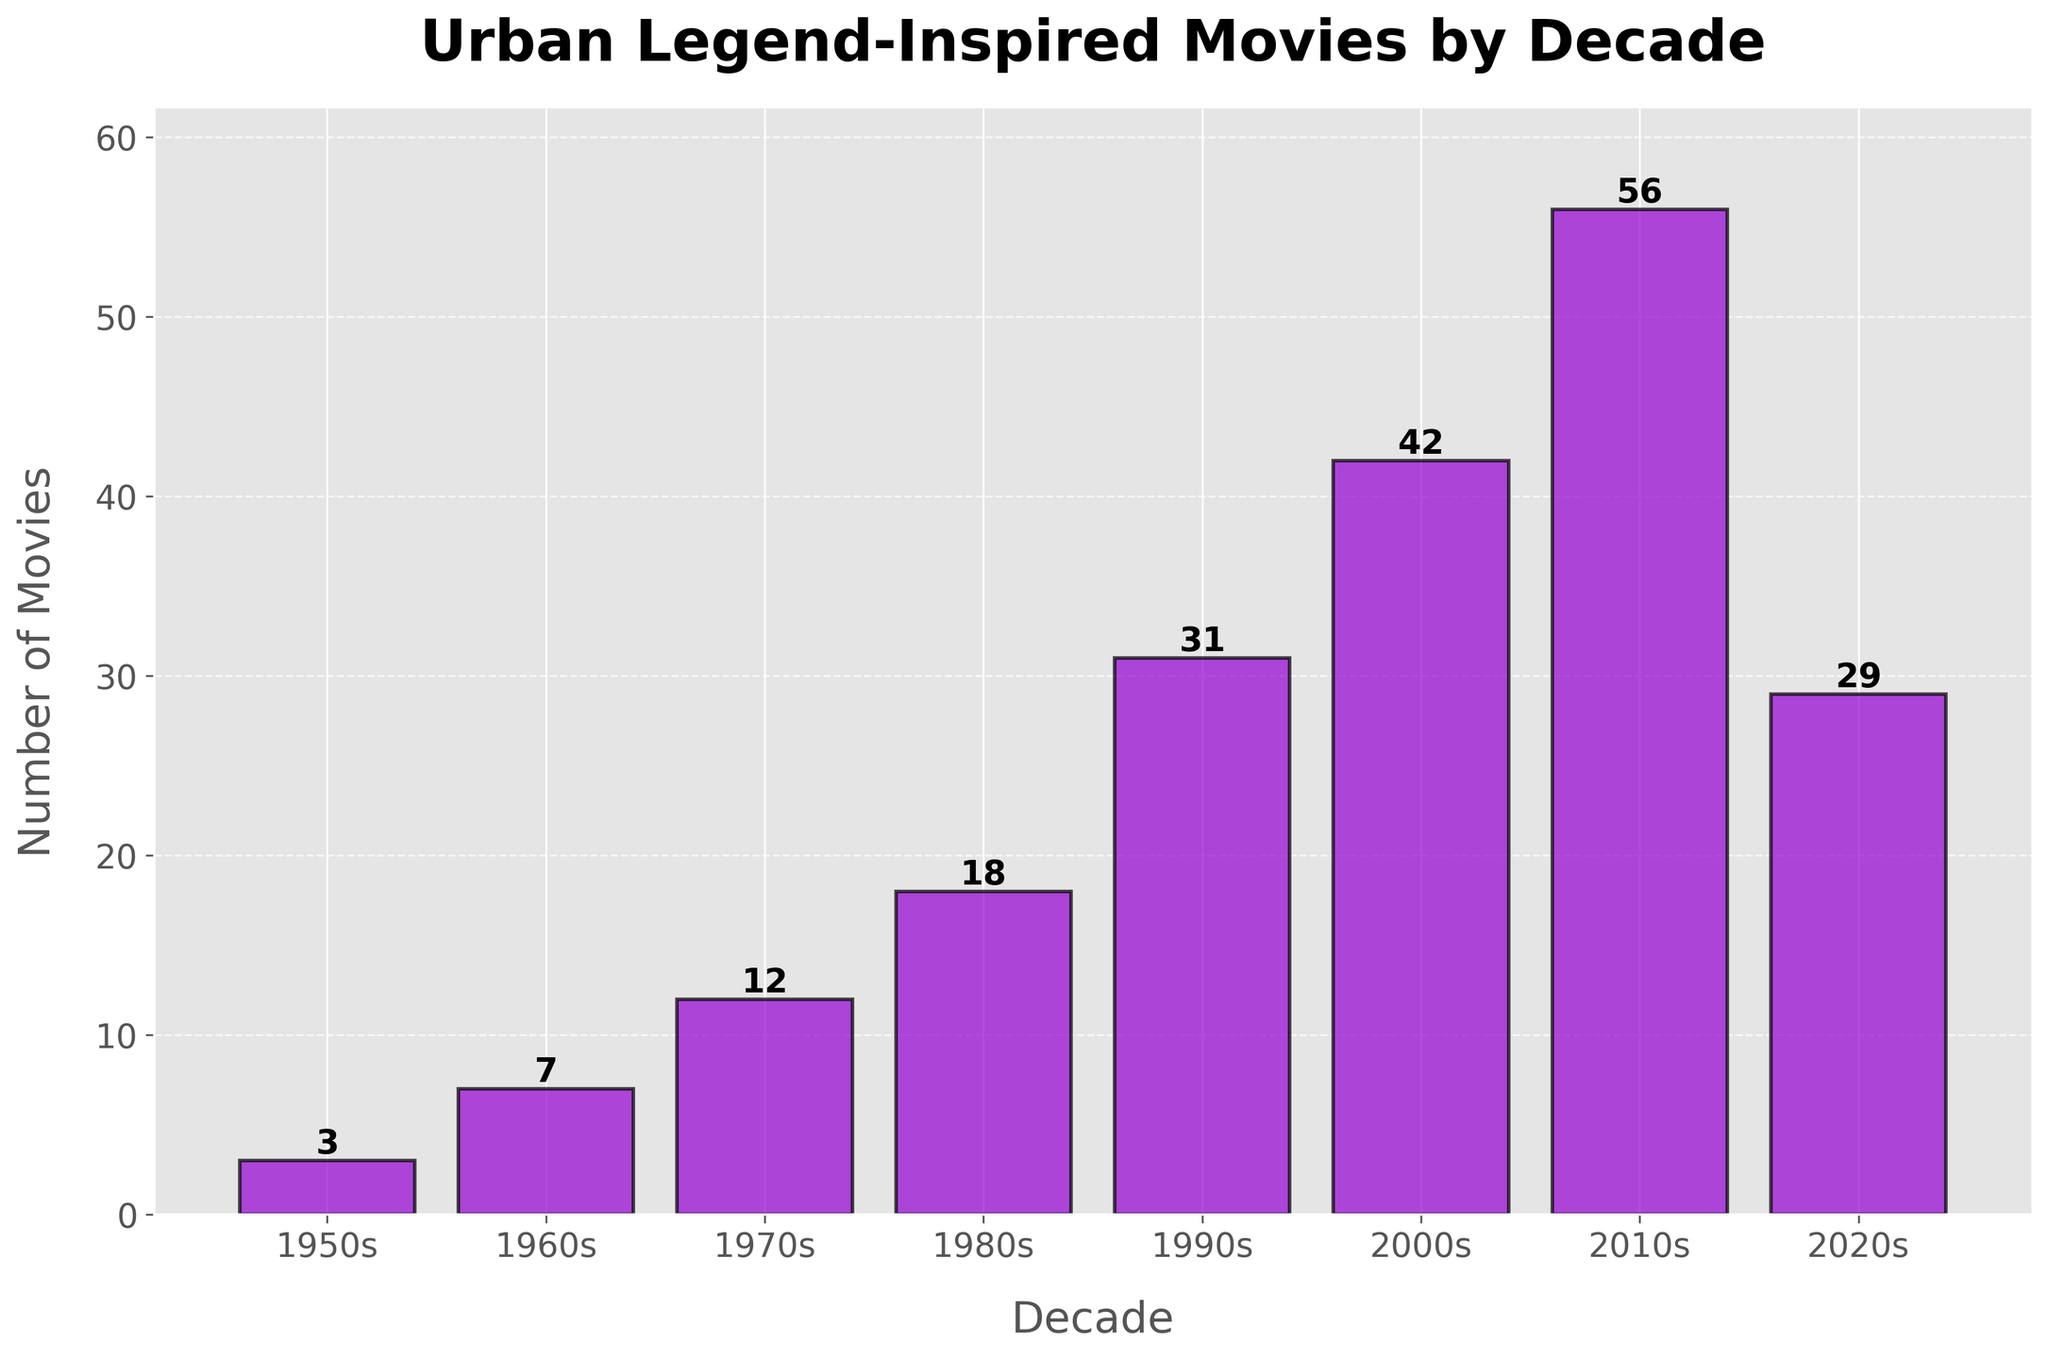Which decade saw the highest number of urban legend-inspired movies produced? The height of the bar representing the 2010s is the tallest in the chart, indicating the highest number of urban legend-inspired movies.
Answer: 2010s How many urban legend-inspired movies were produced in the 1990s and the 2000s combined? The bar for the 1990s reaches 31, and for the 2000s, it reaches 42. Adding these values: 31 + 42 = 73.
Answer: 73 What is the difference between the number of movies produced in the 2010s and the 2020s? The bar for the 2010s reaches 56 movies, and the bar for the 2020s reaches 29. The difference is 56 - 29 = 27.
Answer: 27 Is the number of movies produced in the 1980s greater than in the 1970s? The height of the bar for the 1980s (18) is taller than the bar for the 1970s (12).
Answer: Yes What is the average number of urban legend-inspired movies produced per decade from the 1950s to the 2020s? Adding up the number of movies for each decade: 3 + 7 + 12 + 18 + 31 + 42 + 56 + 29 = 198, then dividing by the number of decades (8): 198 / 8 = 24.75.
Answer: 24.75 